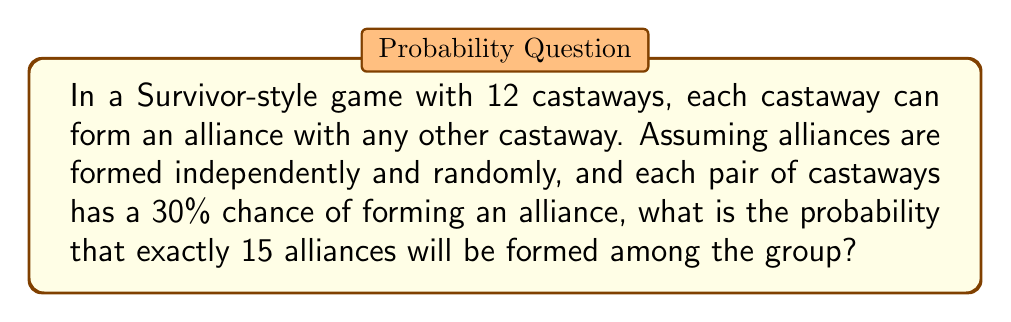What is the answer to this math problem? Let's approach this step-by-step:

1) First, we need to calculate the total number of possible alliances. With 12 castaways, this is given by the combination formula:

   $$\binom{12}{2} = \frac{12!}{2!(12-2)!} = 66$$

2) Now, we have a binomial probability problem. We want the probability of exactly 15 successes (alliances formed) out of 66 trials, where each trial has a 30% chance of success.

3) The probability mass function for a binomial distribution is:

   $$P(X=k) = \binom{n}{k} p^k (1-p)^{n-k}$$

   Where:
   $n$ = number of trials (66)
   $k$ = number of successes (15)
   $p$ = probability of success on each trial (0.3)

4) Plugging in our values:

   $$P(X=15) = \binom{66}{15} (0.3)^{15} (1-0.3)^{66-15}$$

5) Simplify:

   $$P(X=15) = \binom{66}{15} (0.3)^{15} (0.7)^{51}$$

6) Calculate:

   $$P(X=15) \approx 8.0999 \times 10^{-8}$$

This extremely low probability suggests that it's very unlikely to have exactly 15 alliances formed under these conditions.
Answer: $8.0999 \times 10^{-8}$ 